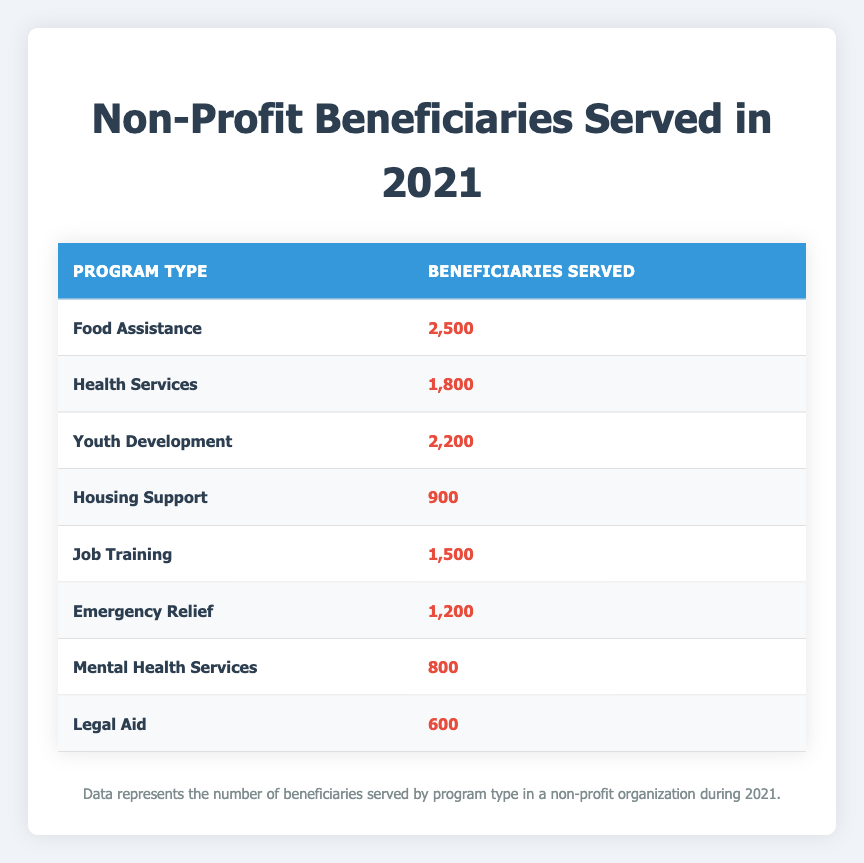What is the total number of beneficiaries served across all program types? To find the total number of beneficiaries, add up the beneficiaries served for each program type: 2500 (Food Assistance) + 1800 (Health Services) + 2200 (Youth Development) + 900 (Housing Support) + 1500 (Job Training) + 1200 (Emergency Relief) + 800 (Mental Health Services) + 600 (Legal Aid) =  1,2500
Answer: 14,600 Which program type served the highest number of beneficiaries? By comparing the number of beneficiaries served across all program types, Food Assistance has the highest number at 2500 beneficiaries.
Answer: Food Assistance How many more beneficiaries did Youth Development serve compared to Mental Health Services? To find the difference, subtract the number of beneficiaries served by Mental Health Services (800) from those served by Youth Development (2200): 2200 - 800 = 1400.
Answer: 1400 Is the number of beneficiaries served by Legal Aid greater than that served by Housing Support? Legal Aid served 600 beneficiaries, while Housing Support served 900. Since 600 is less than 900, the statement is false.
Answer: No What is the average number of beneficiaries served by the programs that provide Health Services and Job Training? To calculate the average, first find the total beneficiaries for Health Services (1800) and Job Training (1500) which is 1800 + 1500 = 3300. Then divide by the number of programs (2): 3300 / 2 = 1650.
Answer: 1650 How many program types served less than 1000 beneficiaries? By analyzing the table, the program types with fewer than 1000 beneficiaries are Housing Support (900), Mental Health Services (800), and Legal Aid (600), totaling 3 program types.
Answer: 3 What is the difference in the number of beneficiaries served between the program types with the most and the least beneficiaries? The program type with the most beneficiaries is Food Assistance (2500) and the least is Legal Aid (600). To find the difference, subtract Legal Aid from Food Assistance: 2500 - 600 = 1900.
Answer: 1900 Did more beneficiaries receive Food Assistance than Emergency Relief? Food Assistance served 2500 beneficiaries, while Emergency Relief served 1200. Since 2500 is greater than 1200, the statement is true.
Answer: Yes 